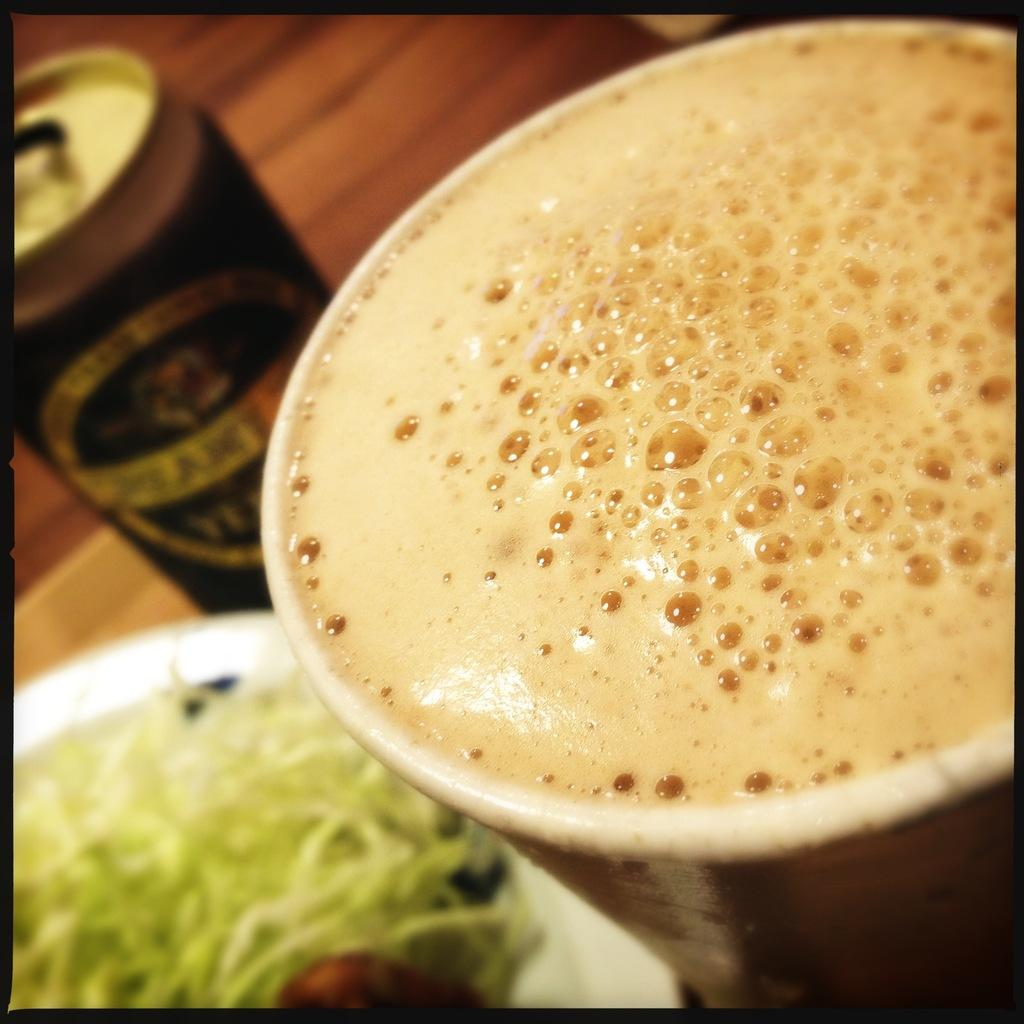What object is located on the left side of the image? There is a tin on the left side of the image. What can be found next to the tin on the left side of the image? There is a plate with a food item on the left side of the image. What is on the right side of the image? There is a glass with a drink on the right side of the image. What type of clouds can be seen in the image? There are no clouds present in the image. How many friends are visible in the image? There is no mention of friends in the image; it only features a tin, a plate with a food item, and a glass with a drink. 